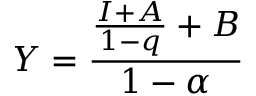Convert formula to latex. <formula><loc_0><loc_0><loc_500><loc_500>Y = { \frac { { \frac { I + A } { 1 - q } } + B } { 1 - \alpha } } \,</formula> 